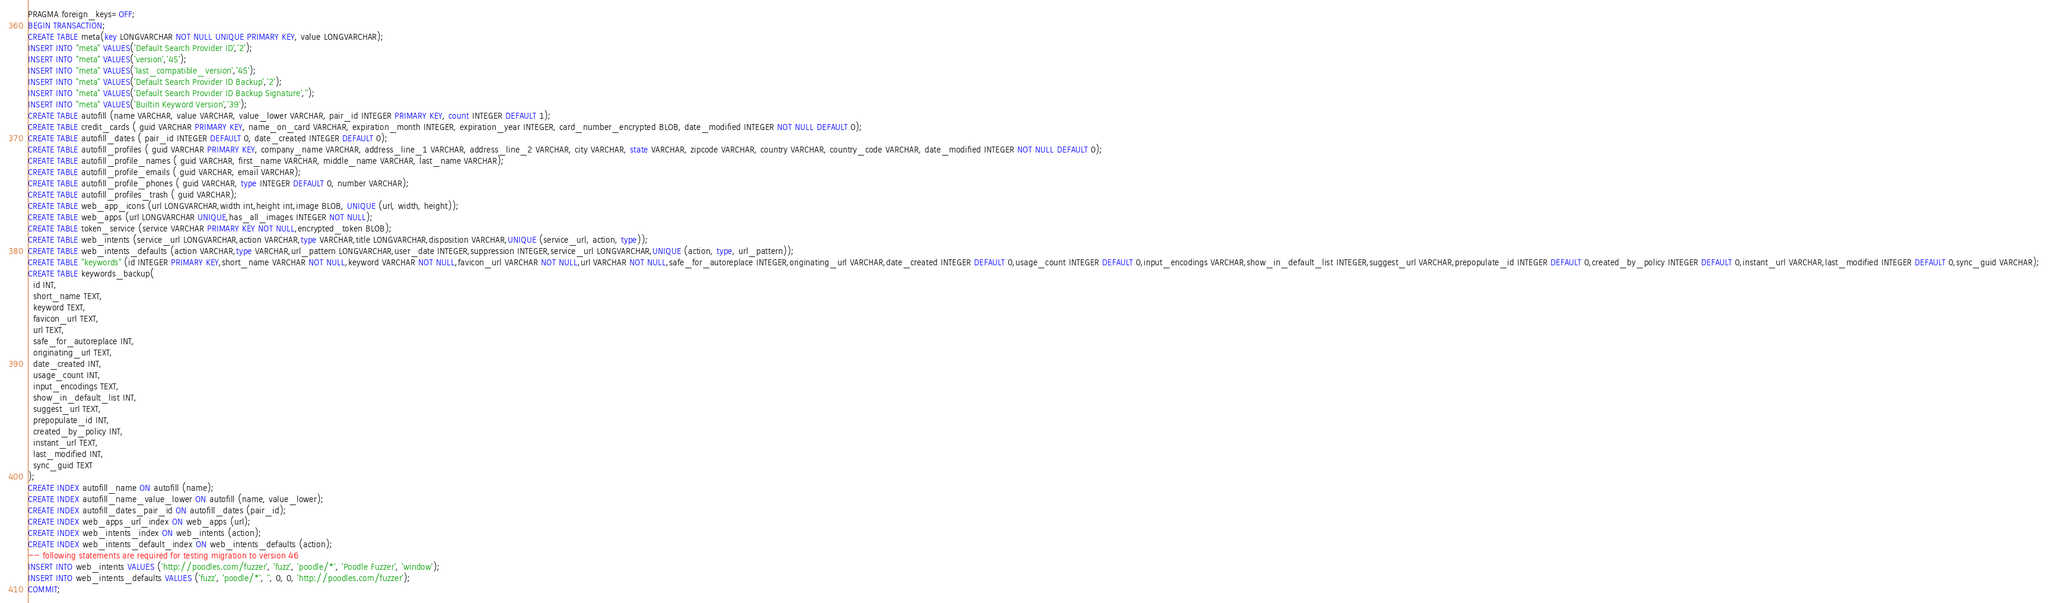<code> <loc_0><loc_0><loc_500><loc_500><_SQL_>PRAGMA foreign_keys=OFF;
BEGIN TRANSACTION;
CREATE TABLE meta(key LONGVARCHAR NOT NULL UNIQUE PRIMARY KEY, value LONGVARCHAR);
INSERT INTO "meta" VALUES('Default Search Provider ID','2');
INSERT INTO "meta" VALUES('version','45');
INSERT INTO "meta" VALUES('last_compatible_version','45');
INSERT INTO "meta" VALUES('Default Search Provider ID Backup','2');
INSERT INTO "meta" VALUES('Default Search Provider ID Backup Signature','');
INSERT INTO "meta" VALUES('Builtin Keyword Version','39');
CREATE TABLE autofill (name VARCHAR, value VARCHAR, value_lower VARCHAR, pair_id INTEGER PRIMARY KEY, count INTEGER DEFAULT 1);
CREATE TABLE credit_cards ( guid VARCHAR PRIMARY KEY, name_on_card VARCHAR, expiration_month INTEGER, expiration_year INTEGER, card_number_encrypted BLOB, date_modified INTEGER NOT NULL DEFAULT 0);
CREATE TABLE autofill_dates ( pair_id INTEGER DEFAULT 0, date_created INTEGER DEFAULT 0);
CREATE TABLE autofill_profiles ( guid VARCHAR PRIMARY KEY, company_name VARCHAR, address_line_1 VARCHAR, address_line_2 VARCHAR, city VARCHAR, state VARCHAR, zipcode VARCHAR, country VARCHAR, country_code VARCHAR, date_modified INTEGER NOT NULL DEFAULT 0);
CREATE TABLE autofill_profile_names ( guid VARCHAR, first_name VARCHAR, middle_name VARCHAR, last_name VARCHAR);
CREATE TABLE autofill_profile_emails ( guid VARCHAR, email VARCHAR);
CREATE TABLE autofill_profile_phones ( guid VARCHAR, type INTEGER DEFAULT 0, number VARCHAR);
CREATE TABLE autofill_profiles_trash ( guid VARCHAR);
CREATE TABLE web_app_icons (url LONGVARCHAR,width int,height int,image BLOB, UNIQUE (url, width, height));
CREATE TABLE web_apps (url LONGVARCHAR UNIQUE,has_all_images INTEGER NOT NULL);
CREATE TABLE token_service (service VARCHAR PRIMARY KEY NOT NULL,encrypted_token BLOB);
CREATE TABLE web_intents (service_url LONGVARCHAR,action VARCHAR,type VARCHAR,title LONGVARCHAR,disposition VARCHAR,UNIQUE (service_url, action, type));
CREATE TABLE web_intents_defaults (action VARCHAR,type VARCHAR,url_pattern LONGVARCHAR,user_date INTEGER,suppression INTEGER,service_url LONGVARCHAR,UNIQUE (action, type, url_pattern));
CREATE TABLE "keywords" (id INTEGER PRIMARY KEY,short_name VARCHAR NOT NULL,keyword VARCHAR NOT NULL,favicon_url VARCHAR NOT NULL,url VARCHAR NOT NULL,safe_for_autoreplace INTEGER,originating_url VARCHAR,date_created INTEGER DEFAULT 0,usage_count INTEGER DEFAULT 0,input_encodings VARCHAR,show_in_default_list INTEGER,suggest_url VARCHAR,prepopulate_id INTEGER DEFAULT 0,created_by_policy INTEGER DEFAULT 0,instant_url VARCHAR,last_modified INTEGER DEFAULT 0,sync_guid VARCHAR);
CREATE TABLE keywords_backup(
  id INT,
  short_name TEXT,
  keyword TEXT,
  favicon_url TEXT,
  url TEXT,
  safe_for_autoreplace INT,
  originating_url TEXT,
  date_created INT,
  usage_count INT,
  input_encodings TEXT,
  show_in_default_list INT,
  suggest_url TEXT,
  prepopulate_id INT,
  created_by_policy INT,
  instant_url TEXT,
  last_modified INT,
  sync_guid TEXT
);
CREATE INDEX autofill_name ON autofill (name);
CREATE INDEX autofill_name_value_lower ON autofill (name, value_lower);
CREATE INDEX autofill_dates_pair_id ON autofill_dates (pair_id);
CREATE INDEX web_apps_url_index ON web_apps (url);
CREATE INDEX web_intents_index ON web_intents (action);
CREATE INDEX web_intents_default_index ON web_intents_defaults (action);
-- following statements are required for testing migration to version 46
INSERT INTO web_intents VALUES ('http://poodles.com/fuzzer', 'fuzz', 'poodle/*', 'Poodle Fuzzer', 'window');
INSERT INTO web_intents_defaults VALUES ('fuzz', 'poodle/*', '', 0, 0, 'http://poodles.com/fuzzer');
COMMIT;

</code> 